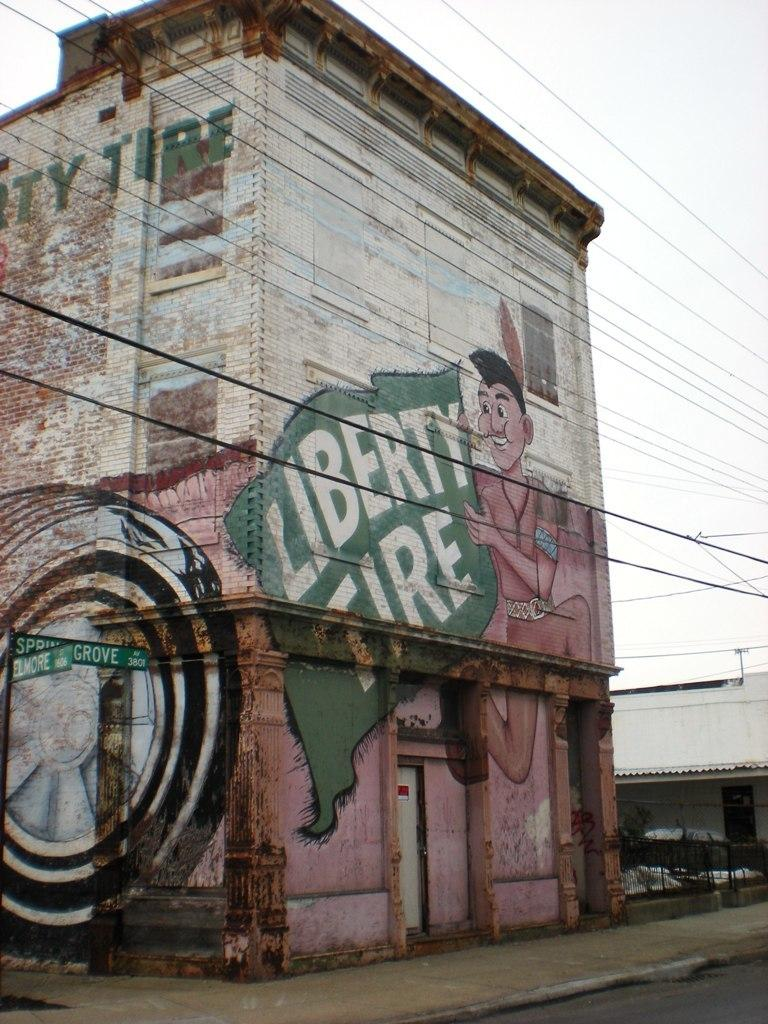What is the main structure visible in the image? There is a building in the image. Are there any decorations or features on the building? Yes, there are paintings on the building. What else can be seen in front of the building? There are a lot of wires in front of the building. How many women are rowing the boat in the image? There is no boat or women present in the image; it features a building with paintings and wires in front of it. 